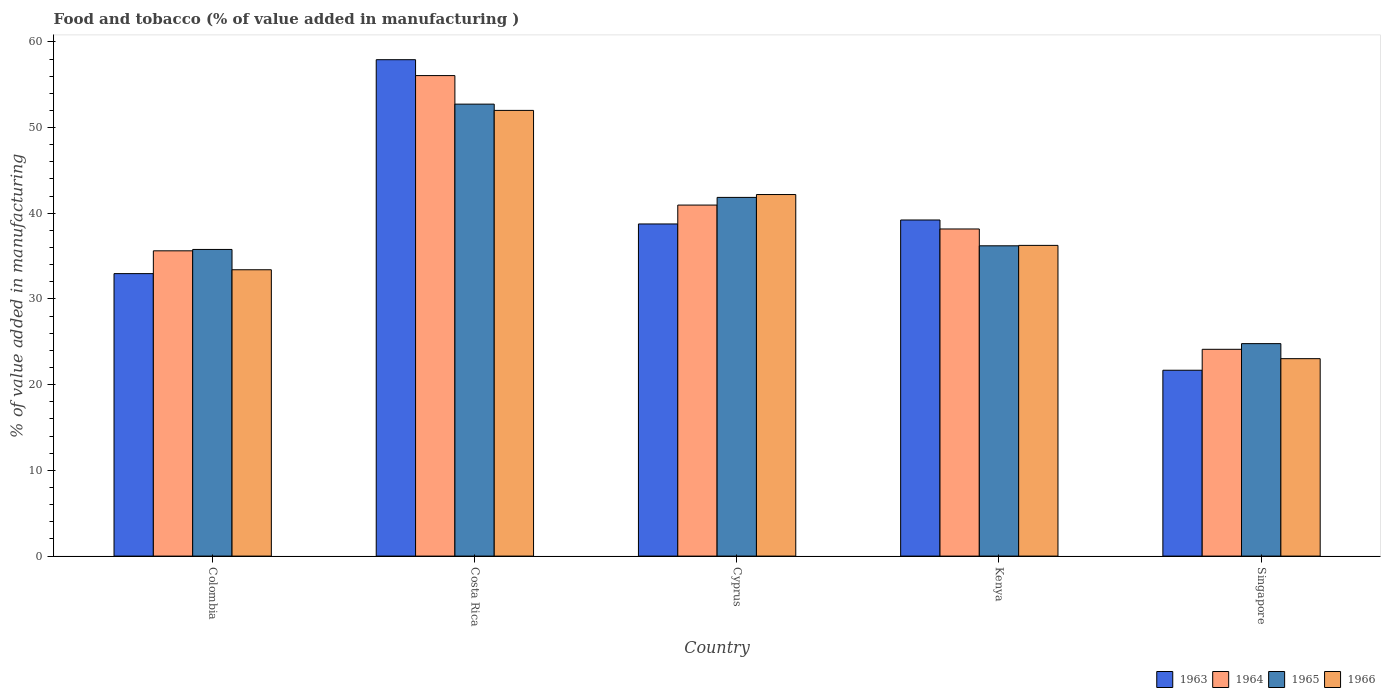How many different coloured bars are there?
Your answer should be compact. 4. Are the number of bars per tick equal to the number of legend labels?
Give a very brief answer. Yes. What is the value added in manufacturing food and tobacco in 1963 in Singapore?
Give a very brief answer. 21.69. Across all countries, what is the maximum value added in manufacturing food and tobacco in 1965?
Your response must be concise. 52.73. Across all countries, what is the minimum value added in manufacturing food and tobacco in 1964?
Keep it short and to the point. 24.13. In which country was the value added in manufacturing food and tobacco in 1963 maximum?
Offer a very short reply. Costa Rica. In which country was the value added in manufacturing food and tobacco in 1966 minimum?
Provide a succinct answer. Singapore. What is the total value added in manufacturing food and tobacco in 1965 in the graph?
Make the answer very short. 191.36. What is the difference between the value added in manufacturing food and tobacco in 1964 in Costa Rica and that in Cyprus?
Offer a very short reply. 15.11. What is the difference between the value added in manufacturing food and tobacco in 1963 in Costa Rica and the value added in manufacturing food and tobacco in 1964 in Cyprus?
Your response must be concise. 16.96. What is the average value added in manufacturing food and tobacco in 1966 per country?
Make the answer very short. 37.38. What is the difference between the value added in manufacturing food and tobacco of/in 1966 and value added in manufacturing food and tobacco of/in 1964 in Singapore?
Give a very brief answer. -1.09. In how many countries, is the value added in manufacturing food and tobacco in 1965 greater than 20 %?
Your answer should be compact. 5. What is the ratio of the value added in manufacturing food and tobacco in 1965 in Colombia to that in Singapore?
Ensure brevity in your answer.  1.44. Is the value added in manufacturing food and tobacco in 1965 in Colombia less than that in Kenya?
Offer a very short reply. Yes. What is the difference between the highest and the second highest value added in manufacturing food and tobacco in 1965?
Offer a very short reply. -10.88. What is the difference between the highest and the lowest value added in manufacturing food and tobacco in 1965?
Ensure brevity in your answer.  27.94. What does the 2nd bar from the left in Kenya represents?
Keep it short and to the point. 1964. How many bars are there?
Provide a short and direct response. 20. Does the graph contain grids?
Keep it short and to the point. No. What is the title of the graph?
Give a very brief answer. Food and tobacco (% of value added in manufacturing ). Does "1992" appear as one of the legend labels in the graph?
Offer a very short reply. No. What is the label or title of the X-axis?
Give a very brief answer. Country. What is the label or title of the Y-axis?
Provide a succinct answer. % of value added in manufacturing. What is the % of value added in manufacturing in 1963 in Colombia?
Provide a short and direct response. 32.96. What is the % of value added in manufacturing of 1964 in Colombia?
Offer a very short reply. 35.62. What is the % of value added in manufacturing in 1965 in Colombia?
Offer a terse response. 35.78. What is the % of value added in manufacturing in 1966 in Colombia?
Provide a succinct answer. 33.41. What is the % of value added in manufacturing of 1963 in Costa Rica?
Offer a very short reply. 57.92. What is the % of value added in manufacturing in 1964 in Costa Rica?
Keep it short and to the point. 56.07. What is the % of value added in manufacturing of 1965 in Costa Rica?
Your answer should be compact. 52.73. What is the % of value added in manufacturing of 1966 in Costa Rica?
Offer a terse response. 52. What is the % of value added in manufacturing in 1963 in Cyprus?
Ensure brevity in your answer.  38.75. What is the % of value added in manufacturing in 1964 in Cyprus?
Make the answer very short. 40.96. What is the % of value added in manufacturing of 1965 in Cyprus?
Ensure brevity in your answer.  41.85. What is the % of value added in manufacturing in 1966 in Cyprus?
Provide a short and direct response. 42.19. What is the % of value added in manufacturing of 1963 in Kenya?
Offer a very short reply. 39.22. What is the % of value added in manufacturing in 1964 in Kenya?
Offer a terse response. 38.17. What is the % of value added in manufacturing in 1965 in Kenya?
Give a very brief answer. 36.2. What is the % of value added in manufacturing in 1966 in Kenya?
Provide a succinct answer. 36.25. What is the % of value added in manufacturing of 1963 in Singapore?
Your answer should be very brief. 21.69. What is the % of value added in manufacturing of 1964 in Singapore?
Keep it short and to the point. 24.13. What is the % of value added in manufacturing of 1965 in Singapore?
Your response must be concise. 24.79. What is the % of value added in manufacturing in 1966 in Singapore?
Your response must be concise. 23.04. Across all countries, what is the maximum % of value added in manufacturing in 1963?
Ensure brevity in your answer.  57.92. Across all countries, what is the maximum % of value added in manufacturing of 1964?
Provide a succinct answer. 56.07. Across all countries, what is the maximum % of value added in manufacturing in 1965?
Make the answer very short. 52.73. Across all countries, what is the maximum % of value added in manufacturing of 1966?
Provide a succinct answer. 52. Across all countries, what is the minimum % of value added in manufacturing in 1963?
Give a very brief answer. 21.69. Across all countries, what is the minimum % of value added in manufacturing of 1964?
Your answer should be compact. 24.13. Across all countries, what is the minimum % of value added in manufacturing in 1965?
Provide a succinct answer. 24.79. Across all countries, what is the minimum % of value added in manufacturing in 1966?
Provide a succinct answer. 23.04. What is the total % of value added in manufacturing of 1963 in the graph?
Provide a succinct answer. 190.54. What is the total % of value added in manufacturing in 1964 in the graph?
Your answer should be very brief. 194.94. What is the total % of value added in manufacturing of 1965 in the graph?
Offer a very short reply. 191.36. What is the total % of value added in manufacturing of 1966 in the graph?
Provide a short and direct response. 186.89. What is the difference between the % of value added in manufacturing in 1963 in Colombia and that in Costa Rica?
Make the answer very short. -24.96. What is the difference between the % of value added in manufacturing in 1964 in Colombia and that in Costa Rica?
Ensure brevity in your answer.  -20.45. What is the difference between the % of value added in manufacturing of 1965 in Colombia and that in Costa Rica?
Your response must be concise. -16.95. What is the difference between the % of value added in manufacturing of 1966 in Colombia and that in Costa Rica?
Give a very brief answer. -18.59. What is the difference between the % of value added in manufacturing of 1963 in Colombia and that in Cyprus?
Give a very brief answer. -5.79. What is the difference between the % of value added in manufacturing of 1964 in Colombia and that in Cyprus?
Give a very brief answer. -5.34. What is the difference between the % of value added in manufacturing of 1965 in Colombia and that in Cyprus?
Make the answer very short. -6.07. What is the difference between the % of value added in manufacturing of 1966 in Colombia and that in Cyprus?
Your answer should be compact. -8.78. What is the difference between the % of value added in manufacturing of 1963 in Colombia and that in Kenya?
Offer a very short reply. -6.26. What is the difference between the % of value added in manufacturing of 1964 in Colombia and that in Kenya?
Give a very brief answer. -2.55. What is the difference between the % of value added in manufacturing of 1965 in Colombia and that in Kenya?
Offer a terse response. -0.42. What is the difference between the % of value added in manufacturing of 1966 in Colombia and that in Kenya?
Keep it short and to the point. -2.84. What is the difference between the % of value added in manufacturing of 1963 in Colombia and that in Singapore?
Make the answer very short. 11.27. What is the difference between the % of value added in manufacturing of 1964 in Colombia and that in Singapore?
Your answer should be compact. 11.49. What is the difference between the % of value added in manufacturing in 1965 in Colombia and that in Singapore?
Offer a terse response. 10.99. What is the difference between the % of value added in manufacturing of 1966 in Colombia and that in Singapore?
Your answer should be very brief. 10.37. What is the difference between the % of value added in manufacturing in 1963 in Costa Rica and that in Cyprus?
Ensure brevity in your answer.  19.17. What is the difference between the % of value added in manufacturing of 1964 in Costa Rica and that in Cyprus?
Your answer should be very brief. 15.11. What is the difference between the % of value added in manufacturing in 1965 in Costa Rica and that in Cyprus?
Keep it short and to the point. 10.88. What is the difference between the % of value added in manufacturing in 1966 in Costa Rica and that in Cyprus?
Offer a terse response. 9.82. What is the difference between the % of value added in manufacturing of 1963 in Costa Rica and that in Kenya?
Provide a short and direct response. 18.7. What is the difference between the % of value added in manufacturing of 1964 in Costa Rica and that in Kenya?
Your answer should be very brief. 17.9. What is the difference between the % of value added in manufacturing of 1965 in Costa Rica and that in Kenya?
Give a very brief answer. 16.53. What is the difference between the % of value added in manufacturing of 1966 in Costa Rica and that in Kenya?
Your answer should be compact. 15.75. What is the difference between the % of value added in manufacturing in 1963 in Costa Rica and that in Singapore?
Provide a succinct answer. 36.23. What is the difference between the % of value added in manufacturing in 1964 in Costa Rica and that in Singapore?
Offer a terse response. 31.94. What is the difference between the % of value added in manufacturing in 1965 in Costa Rica and that in Singapore?
Your response must be concise. 27.94. What is the difference between the % of value added in manufacturing of 1966 in Costa Rica and that in Singapore?
Make the answer very short. 28.97. What is the difference between the % of value added in manufacturing in 1963 in Cyprus and that in Kenya?
Provide a short and direct response. -0.46. What is the difference between the % of value added in manufacturing of 1964 in Cyprus and that in Kenya?
Your answer should be very brief. 2.79. What is the difference between the % of value added in manufacturing in 1965 in Cyprus and that in Kenya?
Provide a short and direct response. 5.65. What is the difference between the % of value added in manufacturing of 1966 in Cyprus and that in Kenya?
Your answer should be compact. 5.93. What is the difference between the % of value added in manufacturing of 1963 in Cyprus and that in Singapore?
Provide a succinct answer. 17.07. What is the difference between the % of value added in manufacturing in 1964 in Cyprus and that in Singapore?
Your response must be concise. 16.83. What is the difference between the % of value added in manufacturing of 1965 in Cyprus and that in Singapore?
Ensure brevity in your answer.  17.06. What is the difference between the % of value added in manufacturing in 1966 in Cyprus and that in Singapore?
Make the answer very short. 19.15. What is the difference between the % of value added in manufacturing in 1963 in Kenya and that in Singapore?
Ensure brevity in your answer.  17.53. What is the difference between the % of value added in manufacturing in 1964 in Kenya and that in Singapore?
Make the answer very short. 14.04. What is the difference between the % of value added in manufacturing of 1965 in Kenya and that in Singapore?
Your answer should be very brief. 11.41. What is the difference between the % of value added in manufacturing of 1966 in Kenya and that in Singapore?
Ensure brevity in your answer.  13.22. What is the difference between the % of value added in manufacturing of 1963 in Colombia and the % of value added in manufacturing of 1964 in Costa Rica?
Your response must be concise. -23.11. What is the difference between the % of value added in manufacturing of 1963 in Colombia and the % of value added in manufacturing of 1965 in Costa Rica?
Ensure brevity in your answer.  -19.77. What is the difference between the % of value added in manufacturing in 1963 in Colombia and the % of value added in manufacturing in 1966 in Costa Rica?
Offer a terse response. -19.04. What is the difference between the % of value added in manufacturing in 1964 in Colombia and the % of value added in manufacturing in 1965 in Costa Rica?
Provide a succinct answer. -17.11. What is the difference between the % of value added in manufacturing in 1964 in Colombia and the % of value added in manufacturing in 1966 in Costa Rica?
Your response must be concise. -16.38. What is the difference between the % of value added in manufacturing of 1965 in Colombia and the % of value added in manufacturing of 1966 in Costa Rica?
Ensure brevity in your answer.  -16.22. What is the difference between the % of value added in manufacturing of 1963 in Colombia and the % of value added in manufacturing of 1964 in Cyprus?
Make the answer very short. -8. What is the difference between the % of value added in manufacturing in 1963 in Colombia and the % of value added in manufacturing in 1965 in Cyprus?
Make the answer very short. -8.89. What is the difference between the % of value added in manufacturing in 1963 in Colombia and the % of value added in manufacturing in 1966 in Cyprus?
Provide a short and direct response. -9.23. What is the difference between the % of value added in manufacturing of 1964 in Colombia and the % of value added in manufacturing of 1965 in Cyprus?
Your answer should be very brief. -6.23. What is the difference between the % of value added in manufacturing of 1964 in Colombia and the % of value added in manufacturing of 1966 in Cyprus?
Make the answer very short. -6.57. What is the difference between the % of value added in manufacturing in 1965 in Colombia and the % of value added in manufacturing in 1966 in Cyprus?
Your answer should be compact. -6.41. What is the difference between the % of value added in manufacturing in 1963 in Colombia and the % of value added in manufacturing in 1964 in Kenya?
Your response must be concise. -5.21. What is the difference between the % of value added in manufacturing in 1963 in Colombia and the % of value added in manufacturing in 1965 in Kenya?
Offer a very short reply. -3.24. What is the difference between the % of value added in manufacturing of 1963 in Colombia and the % of value added in manufacturing of 1966 in Kenya?
Provide a succinct answer. -3.29. What is the difference between the % of value added in manufacturing in 1964 in Colombia and the % of value added in manufacturing in 1965 in Kenya?
Offer a terse response. -0.58. What is the difference between the % of value added in manufacturing in 1964 in Colombia and the % of value added in manufacturing in 1966 in Kenya?
Your answer should be very brief. -0.63. What is the difference between the % of value added in manufacturing in 1965 in Colombia and the % of value added in manufacturing in 1966 in Kenya?
Your answer should be very brief. -0.47. What is the difference between the % of value added in manufacturing of 1963 in Colombia and the % of value added in manufacturing of 1964 in Singapore?
Your answer should be very brief. 8.83. What is the difference between the % of value added in manufacturing of 1963 in Colombia and the % of value added in manufacturing of 1965 in Singapore?
Your answer should be very brief. 8.17. What is the difference between the % of value added in manufacturing in 1963 in Colombia and the % of value added in manufacturing in 1966 in Singapore?
Your answer should be compact. 9.92. What is the difference between the % of value added in manufacturing in 1964 in Colombia and the % of value added in manufacturing in 1965 in Singapore?
Offer a terse response. 10.83. What is the difference between the % of value added in manufacturing in 1964 in Colombia and the % of value added in manufacturing in 1966 in Singapore?
Offer a very short reply. 12.58. What is the difference between the % of value added in manufacturing in 1965 in Colombia and the % of value added in manufacturing in 1966 in Singapore?
Ensure brevity in your answer.  12.74. What is the difference between the % of value added in manufacturing in 1963 in Costa Rica and the % of value added in manufacturing in 1964 in Cyprus?
Ensure brevity in your answer.  16.96. What is the difference between the % of value added in manufacturing in 1963 in Costa Rica and the % of value added in manufacturing in 1965 in Cyprus?
Make the answer very short. 16.07. What is the difference between the % of value added in manufacturing in 1963 in Costa Rica and the % of value added in manufacturing in 1966 in Cyprus?
Offer a very short reply. 15.73. What is the difference between the % of value added in manufacturing in 1964 in Costa Rica and the % of value added in manufacturing in 1965 in Cyprus?
Offer a very short reply. 14.21. What is the difference between the % of value added in manufacturing in 1964 in Costa Rica and the % of value added in manufacturing in 1966 in Cyprus?
Offer a terse response. 13.88. What is the difference between the % of value added in manufacturing of 1965 in Costa Rica and the % of value added in manufacturing of 1966 in Cyprus?
Make the answer very short. 10.55. What is the difference between the % of value added in manufacturing in 1963 in Costa Rica and the % of value added in manufacturing in 1964 in Kenya?
Your answer should be very brief. 19.75. What is the difference between the % of value added in manufacturing of 1963 in Costa Rica and the % of value added in manufacturing of 1965 in Kenya?
Offer a very short reply. 21.72. What is the difference between the % of value added in manufacturing of 1963 in Costa Rica and the % of value added in manufacturing of 1966 in Kenya?
Your answer should be very brief. 21.67. What is the difference between the % of value added in manufacturing in 1964 in Costa Rica and the % of value added in manufacturing in 1965 in Kenya?
Give a very brief answer. 19.86. What is the difference between the % of value added in manufacturing in 1964 in Costa Rica and the % of value added in manufacturing in 1966 in Kenya?
Your response must be concise. 19.81. What is the difference between the % of value added in manufacturing of 1965 in Costa Rica and the % of value added in manufacturing of 1966 in Kenya?
Offer a very short reply. 16.48. What is the difference between the % of value added in manufacturing in 1963 in Costa Rica and the % of value added in manufacturing in 1964 in Singapore?
Provide a short and direct response. 33.79. What is the difference between the % of value added in manufacturing of 1963 in Costa Rica and the % of value added in manufacturing of 1965 in Singapore?
Give a very brief answer. 33.13. What is the difference between the % of value added in manufacturing of 1963 in Costa Rica and the % of value added in manufacturing of 1966 in Singapore?
Offer a terse response. 34.88. What is the difference between the % of value added in manufacturing of 1964 in Costa Rica and the % of value added in manufacturing of 1965 in Singapore?
Give a very brief answer. 31.28. What is the difference between the % of value added in manufacturing of 1964 in Costa Rica and the % of value added in manufacturing of 1966 in Singapore?
Keep it short and to the point. 33.03. What is the difference between the % of value added in manufacturing in 1965 in Costa Rica and the % of value added in manufacturing in 1966 in Singapore?
Keep it short and to the point. 29.7. What is the difference between the % of value added in manufacturing in 1963 in Cyprus and the % of value added in manufacturing in 1964 in Kenya?
Keep it short and to the point. 0.59. What is the difference between the % of value added in manufacturing in 1963 in Cyprus and the % of value added in manufacturing in 1965 in Kenya?
Give a very brief answer. 2.55. What is the difference between the % of value added in manufacturing in 1963 in Cyprus and the % of value added in manufacturing in 1966 in Kenya?
Ensure brevity in your answer.  2.5. What is the difference between the % of value added in manufacturing in 1964 in Cyprus and the % of value added in manufacturing in 1965 in Kenya?
Ensure brevity in your answer.  4.75. What is the difference between the % of value added in manufacturing in 1964 in Cyprus and the % of value added in manufacturing in 1966 in Kenya?
Ensure brevity in your answer.  4.7. What is the difference between the % of value added in manufacturing of 1965 in Cyprus and the % of value added in manufacturing of 1966 in Kenya?
Offer a terse response. 5.6. What is the difference between the % of value added in manufacturing in 1963 in Cyprus and the % of value added in manufacturing in 1964 in Singapore?
Offer a very short reply. 14.63. What is the difference between the % of value added in manufacturing in 1963 in Cyprus and the % of value added in manufacturing in 1965 in Singapore?
Make the answer very short. 13.96. What is the difference between the % of value added in manufacturing in 1963 in Cyprus and the % of value added in manufacturing in 1966 in Singapore?
Your answer should be compact. 15.72. What is the difference between the % of value added in manufacturing of 1964 in Cyprus and the % of value added in manufacturing of 1965 in Singapore?
Provide a succinct answer. 16.17. What is the difference between the % of value added in manufacturing in 1964 in Cyprus and the % of value added in manufacturing in 1966 in Singapore?
Offer a terse response. 17.92. What is the difference between the % of value added in manufacturing of 1965 in Cyprus and the % of value added in manufacturing of 1966 in Singapore?
Offer a terse response. 18.82. What is the difference between the % of value added in manufacturing of 1963 in Kenya and the % of value added in manufacturing of 1964 in Singapore?
Give a very brief answer. 15.09. What is the difference between the % of value added in manufacturing in 1963 in Kenya and the % of value added in manufacturing in 1965 in Singapore?
Provide a succinct answer. 14.43. What is the difference between the % of value added in manufacturing in 1963 in Kenya and the % of value added in manufacturing in 1966 in Singapore?
Provide a short and direct response. 16.18. What is the difference between the % of value added in manufacturing in 1964 in Kenya and the % of value added in manufacturing in 1965 in Singapore?
Keep it short and to the point. 13.38. What is the difference between the % of value added in manufacturing of 1964 in Kenya and the % of value added in manufacturing of 1966 in Singapore?
Provide a succinct answer. 15.13. What is the difference between the % of value added in manufacturing of 1965 in Kenya and the % of value added in manufacturing of 1966 in Singapore?
Your answer should be very brief. 13.17. What is the average % of value added in manufacturing of 1963 per country?
Keep it short and to the point. 38.11. What is the average % of value added in manufacturing in 1964 per country?
Ensure brevity in your answer.  38.99. What is the average % of value added in manufacturing in 1965 per country?
Offer a terse response. 38.27. What is the average % of value added in manufacturing in 1966 per country?
Your answer should be very brief. 37.38. What is the difference between the % of value added in manufacturing in 1963 and % of value added in manufacturing in 1964 in Colombia?
Your response must be concise. -2.66. What is the difference between the % of value added in manufacturing in 1963 and % of value added in manufacturing in 1965 in Colombia?
Your response must be concise. -2.82. What is the difference between the % of value added in manufacturing in 1963 and % of value added in manufacturing in 1966 in Colombia?
Ensure brevity in your answer.  -0.45. What is the difference between the % of value added in manufacturing of 1964 and % of value added in manufacturing of 1965 in Colombia?
Provide a succinct answer. -0.16. What is the difference between the % of value added in manufacturing in 1964 and % of value added in manufacturing in 1966 in Colombia?
Provide a short and direct response. 2.21. What is the difference between the % of value added in manufacturing of 1965 and % of value added in manufacturing of 1966 in Colombia?
Give a very brief answer. 2.37. What is the difference between the % of value added in manufacturing in 1963 and % of value added in manufacturing in 1964 in Costa Rica?
Your answer should be compact. 1.85. What is the difference between the % of value added in manufacturing in 1963 and % of value added in manufacturing in 1965 in Costa Rica?
Offer a very short reply. 5.19. What is the difference between the % of value added in manufacturing in 1963 and % of value added in manufacturing in 1966 in Costa Rica?
Give a very brief answer. 5.92. What is the difference between the % of value added in manufacturing in 1964 and % of value added in manufacturing in 1965 in Costa Rica?
Provide a succinct answer. 3.33. What is the difference between the % of value added in manufacturing of 1964 and % of value added in manufacturing of 1966 in Costa Rica?
Your response must be concise. 4.06. What is the difference between the % of value added in manufacturing in 1965 and % of value added in manufacturing in 1966 in Costa Rica?
Provide a succinct answer. 0.73. What is the difference between the % of value added in manufacturing of 1963 and % of value added in manufacturing of 1964 in Cyprus?
Offer a very short reply. -2.2. What is the difference between the % of value added in manufacturing of 1963 and % of value added in manufacturing of 1965 in Cyprus?
Your answer should be very brief. -3.1. What is the difference between the % of value added in manufacturing in 1963 and % of value added in manufacturing in 1966 in Cyprus?
Offer a terse response. -3.43. What is the difference between the % of value added in manufacturing of 1964 and % of value added in manufacturing of 1965 in Cyprus?
Ensure brevity in your answer.  -0.9. What is the difference between the % of value added in manufacturing of 1964 and % of value added in manufacturing of 1966 in Cyprus?
Your response must be concise. -1.23. What is the difference between the % of value added in manufacturing of 1963 and % of value added in manufacturing of 1964 in Kenya?
Ensure brevity in your answer.  1.05. What is the difference between the % of value added in manufacturing of 1963 and % of value added in manufacturing of 1965 in Kenya?
Offer a very short reply. 3.01. What is the difference between the % of value added in manufacturing in 1963 and % of value added in manufacturing in 1966 in Kenya?
Your answer should be compact. 2.96. What is the difference between the % of value added in manufacturing of 1964 and % of value added in manufacturing of 1965 in Kenya?
Keep it short and to the point. 1.96. What is the difference between the % of value added in manufacturing of 1964 and % of value added in manufacturing of 1966 in Kenya?
Keep it short and to the point. 1.91. What is the difference between the % of value added in manufacturing in 1965 and % of value added in manufacturing in 1966 in Kenya?
Your response must be concise. -0.05. What is the difference between the % of value added in manufacturing of 1963 and % of value added in manufacturing of 1964 in Singapore?
Provide a succinct answer. -2.44. What is the difference between the % of value added in manufacturing in 1963 and % of value added in manufacturing in 1965 in Singapore?
Offer a very short reply. -3.1. What is the difference between the % of value added in manufacturing in 1963 and % of value added in manufacturing in 1966 in Singapore?
Your answer should be compact. -1.35. What is the difference between the % of value added in manufacturing in 1964 and % of value added in manufacturing in 1965 in Singapore?
Your response must be concise. -0.66. What is the difference between the % of value added in manufacturing of 1964 and % of value added in manufacturing of 1966 in Singapore?
Offer a very short reply. 1.09. What is the difference between the % of value added in manufacturing of 1965 and % of value added in manufacturing of 1966 in Singapore?
Ensure brevity in your answer.  1.75. What is the ratio of the % of value added in manufacturing in 1963 in Colombia to that in Costa Rica?
Your answer should be compact. 0.57. What is the ratio of the % of value added in manufacturing of 1964 in Colombia to that in Costa Rica?
Your response must be concise. 0.64. What is the ratio of the % of value added in manufacturing in 1965 in Colombia to that in Costa Rica?
Make the answer very short. 0.68. What is the ratio of the % of value added in manufacturing in 1966 in Colombia to that in Costa Rica?
Offer a terse response. 0.64. What is the ratio of the % of value added in manufacturing of 1963 in Colombia to that in Cyprus?
Your answer should be very brief. 0.85. What is the ratio of the % of value added in manufacturing in 1964 in Colombia to that in Cyprus?
Provide a short and direct response. 0.87. What is the ratio of the % of value added in manufacturing in 1965 in Colombia to that in Cyprus?
Ensure brevity in your answer.  0.85. What is the ratio of the % of value added in manufacturing of 1966 in Colombia to that in Cyprus?
Your answer should be compact. 0.79. What is the ratio of the % of value added in manufacturing in 1963 in Colombia to that in Kenya?
Make the answer very short. 0.84. What is the ratio of the % of value added in manufacturing of 1964 in Colombia to that in Kenya?
Your response must be concise. 0.93. What is the ratio of the % of value added in manufacturing of 1965 in Colombia to that in Kenya?
Make the answer very short. 0.99. What is the ratio of the % of value added in manufacturing in 1966 in Colombia to that in Kenya?
Provide a short and direct response. 0.92. What is the ratio of the % of value added in manufacturing of 1963 in Colombia to that in Singapore?
Provide a succinct answer. 1.52. What is the ratio of the % of value added in manufacturing of 1964 in Colombia to that in Singapore?
Provide a short and direct response. 1.48. What is the ratio of the % of value added in manufacturing in 1965 in Colombia to that in Singapore?
Your response must be concise. 1.44. What is the ratio of the % of value added in manufacturing in 1966 in Colombia to that in Singapore?
Provide a succinct answer. 1.45. What is the ratio of the % of value added in manufacturing of 1963 in Costa Rica to that in Cyprus?
Provide a succinct answer. 1.49. What is the ratio of the % of value added in manufacturing of 1964 in Costa Rica to that in Cyprus?
Make the answer very short. 1.37. What is the ratio of the % of value added in manufacturing in 1965 in Costa Rica to that in Cyprus?
Provide a succinct answer. 1.26. What is the ratio of the % of value added in manufacturing in 1966 in Costa Rica to that in Cyprus?
Make the answer very short. 1.23. What is the ratio of the % of value added in manufacturing in 1963 in Costa Rica to that in Kenya?
Your response must be concise. 1.48. What is the ratio of the % of value added in manufacturing of 1964 in Costa Rica to that in Kenya?
Keep it short and to the point. 1.47. What is the ratio of the % of value added in manufacturing in 1965 in Costa Rica to that in Kenya?
Your answer should be very brief. 1.46. What is the ratio of the % of value added in manufacturing of 1966 in Costa Rica to that in Kenya?
Ensure brevity in your answer.  1.43. What is the ratio of the % of value added in manufacturing in 1963 in Costa Rica to that in Singapore?
Offer a terse response. 2.67. What is the ratio of the % of value added in manufacturing in 1964 in Costa Rica to that in Singapore?
Offer a terse response. 2.32. What is the ratio of the % of value added in manufacturing in 1965 in Costa Rica to that in Singapore?
Offer a terse response. 2.13. What is the ratio of the % of value added in manufacturing in 1966 in Costa Rica to that in Singapore?
Your answer should be very brief. 2.26. What is the ratio of the % of value added in manufacturing of 1964 in Cyprus to that in Kenya?
Provide a short and direct response. 1.07. What is the ratio of the % of value added in manufacturing of 1965 in Cyprus to that in Kenya?
Provide a succinct answer. 1.16. What is the ratio of the % of value added in manufacturing in 1966 in Cyprus to that in Kenya?
Your answer should be very brief. 1.16. What is the ratio of the % of value added in manufacturing of 1963 in Cyprus to that in Singapore?
Your answer should be compact. 1.79. What is the ratio of the % of value added in manufacturing of 1964 in Cyprus to that in Singapore?
Provide a short and direct response. 1.7. What is the ratio of the % of value added in manufacturing of 1965 in Cyprus to that in Singapore?
Your answer should be compact. 1.69. What is the ratio of the % of value added in manufacturing in 1966 in Cyprus to that in Singapore?
Your answer should be very brief. 1.83. What is the ratio of the % of value added in manufacturing of 1963 in Kenya to that in Singapore?
Provide a succinct answer. 1.81. What is the ratio of the % of value added in manufacturing in 1964 in Kenya to that in Singapore?
Offer a very short reply. 1.58. What is the ratio of the % of value added in manufacturing of 1965 in Kenya to that in Singapore?
Keep it short and to the point. 1.46. What is the ratio of the % of value added in manufacturing in 1966 in Kenya to that in Singapore?
Make the answer very short. 1.57. What is the difference between the highest and the second highest % of value added in manufacturing in 1963?
Give a very brief answer. 18.7. What is the difference between the highest and the second highest % of value added in manufacturing in 1964?
Ensure brevity in your answer.  15.11. What is the difference between the highest and the second highest % of value added in manufacturing in 1965?
Give a very brief answer. 10.88. What is the difference between the highest and the second highest % of value added in manufacturing of 1966?
Your answer should be very brief. 9.82. What is the difference between the highest and the lowest % of value added in manufacturing of 1963?
Your answer should be compact. 36.23. What is the difference between the highest and the lowest % of value added in manufacturing of 1964?
Offer a very short reply. 31.94. What is the difference between the highest and the lowest % of value added in manufacturing of 1965?
Keep it short and to the point. 27.94. What is the difference between the highest and the lowest % of value added in manufacturing of 1966?
Provide a succinct answer. 28.97. 